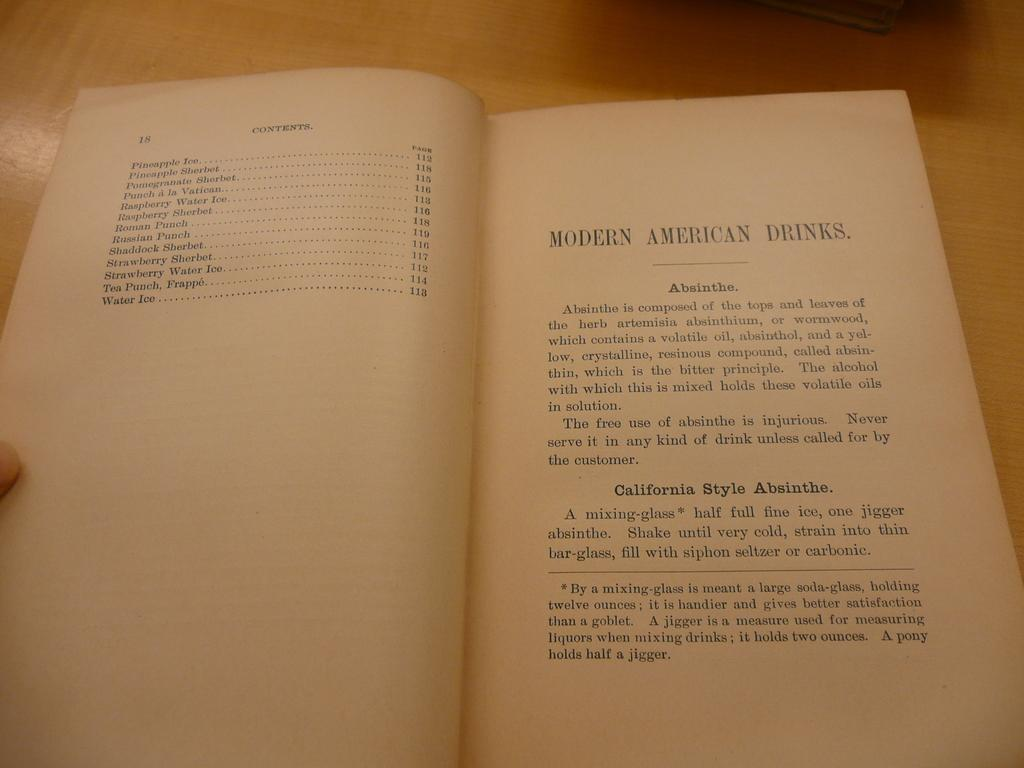<image>
Share a concise interpretation of the image provided. A book is open to the contents page and a section titled modern American drinks. 